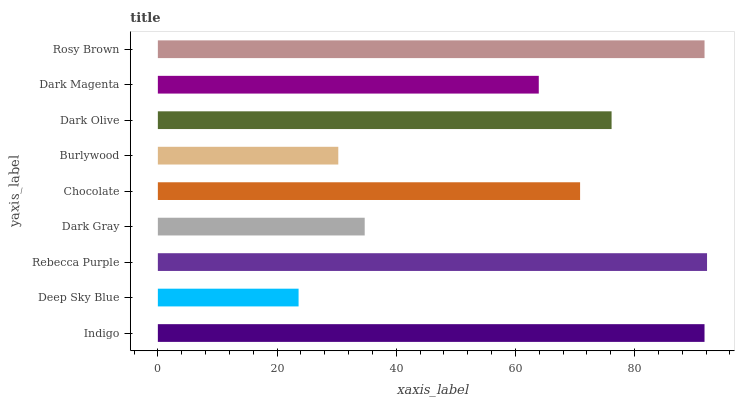Is Deep Sky Blue the minimum?
Answer yes or no. Yes. Is Rebecca Purple the maximum?
Answer yes or no. Yes. Is Rebecca Purple the minimum?
Answer yes or no. No. Is Deep Sky Blue the maximum?
Answer yes or no. No. Is Rebecca Purple greater than Deep Sky Blue?
Answer yes or no. Yes. Is Deep Sky Blue less than Rebecca Purple?
Answer yes or no. Yes. Is Deep Sky Blue greater than Rebecca Purple?
Answer yes or no. No. Is Rebecca Purple less than Deep Sky Blue?
Answer yes or no. No. Is Chocolate the high median?
Answer yes or no. Yes. Is Chocolate the low median?
Answer yes or no. Yes. Is Dark Magenta the high median?
Answer yes or no. No. Is Burlywood the low median?
Answer yes or no. No. 